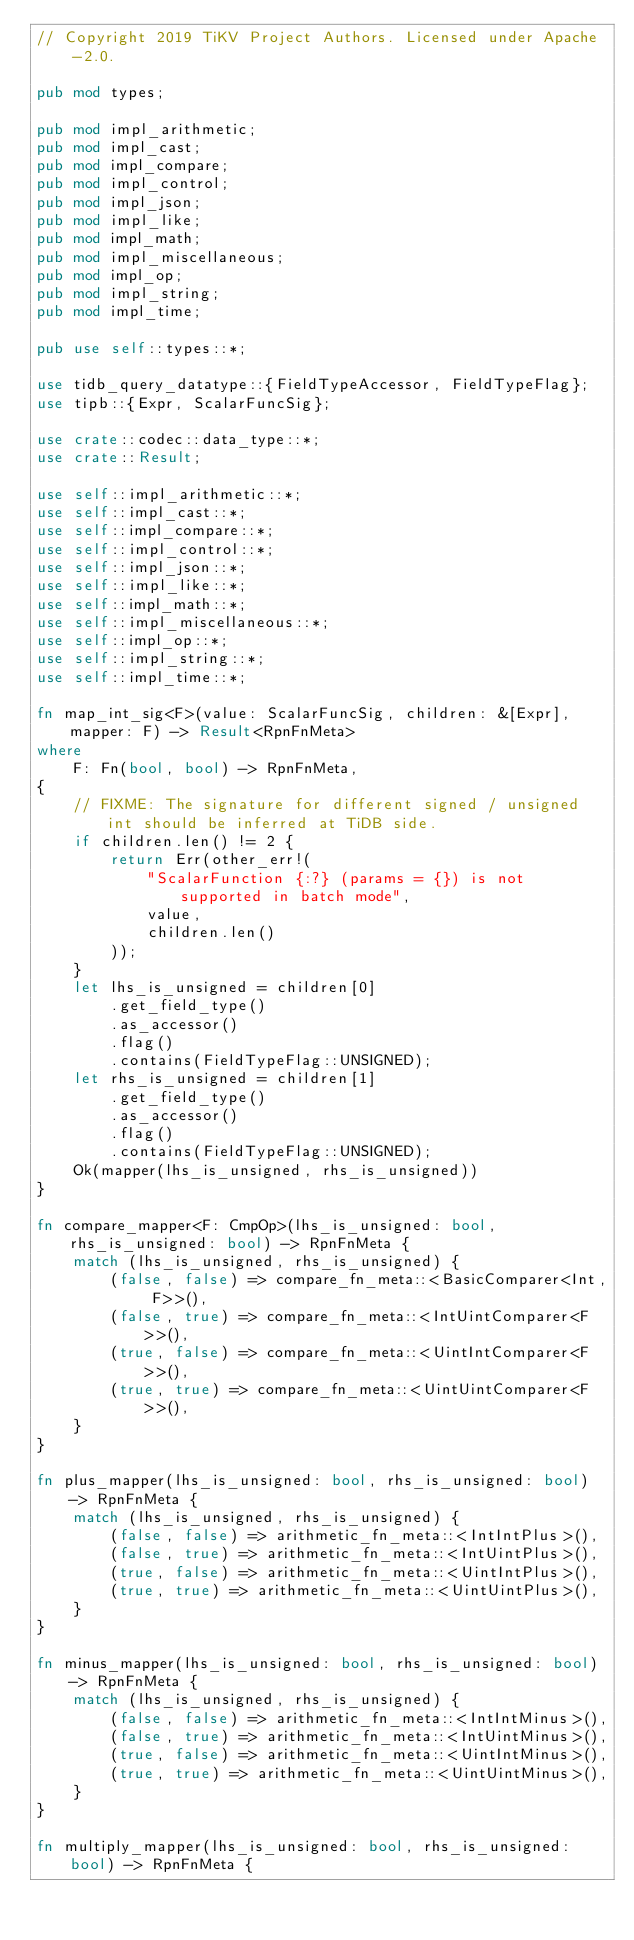<code> <loc_0><loc_0><loc_500><loc_500><_Rust_>// Copyright 2019 TiKV Project Authors. Licensed under Apache-2.0.

pub mod types;

pub mod impl_arithmetic;
pub mod impl_cast;
pub mod impl_compare;
pub mod impl_control;
pub mod impl_json;
pub mod impl_like;
pub mod impl_math;
pub mod impl_miscellaneous;
pub mod impl_op;
pub mod impl_string;
pub mod impl_time;

pub use self::types::*;

use tidb_query_datatype::{FieldTypeAccessor, FieldTypeFlag};
use tipb::{Expr, ScalarFuncSig};

use crate::codec::data_type::*;
use crate::Result;

use self::impl_arithmetic::*;
use self::impl_cast::*;
use self::impl_compare::*;
use self::impl_control::*;
use self::impl_json::*;
use self::impl_like::*;
use self::impl_math::*;
use self::impl_miscellaneous::*;
use self::impl_op::*;
use self::impl_string::*;
use self::impl_time::*;

fn map_int_sig<F>(value: ScalarFuncSig, children: &[Expr], mapper: F) -> Result<RpnFnMeta>
where
    F: Fn(bool, bool) -> RpnFnMeta,
{
    // FIXME: The signature for different signed / unsigned int should be inferred at TiDB side.
    if children.len() != 2 {
        return Err(other_err!(
            "ScalarFunction {:?} (params = {}) is not supported in batch mode",
            value,
            children.len()
        ));
    }
    let lhs_is_unsigned = children[0]
        .get_field_type()
        .as_accessor()
        .flag()
        .contains(FieldTypeFlag::UNSIGNED);
    let rhs_is_unsigned = children[1]
        .get_field_type()
        .as_accessor()
        .flag()
        .contains(FieldTypeFlag::UNSIGNED);
    Ok(mapper(lhs_is_unsigned, rhs_is_unsigned))
}

fn compare_mapper<F: CmpOp>(lhs_is_unsigned: bool, rhs_is_unsigned: bool) -> RpnFnMeta {
    match (lhs_is_unsigned, rhs_is_unsigned) {
        (false, false) => compare_fn_meta::<BasicComparer<Int, F>>(),
        (false, true) => compare_fn_meta::<IntUintComparer<F>>(),
        (true, false) => compare_fn_meta::<UintIntComparer<F>>(),
        (true, true) => compare_fn_meta::<UintUintComparer<F>>(),
    }
}

fn plus_mapper(lhs_is_unsigned: bool, rhs_is_unsigned: bool) -> RpnFnMeta {
    match (lhs_is_unsigned, rhs_is_unsigned) {
        (false, false) => arithmetic_fn_meta::<IntIntPlus>(),
        (false, true) => arithmetic_fn_meta::<IntUintPlus>(),
        (true, false) => arithmetic_fn_meta::<UintIntPlus>(),
        (true, true) => arithmetic_fn_meta::<UintUintPlus>(),
    }
}

fn minus_mapper(lhs_is_unsigned: bool, rhs_is_unsigned: bool) -> RpnFnMeta {
    match (lhs_is_unsigned, rhs_is_unsigned) {
        (false, false) => arithmetic_fn_meta::<IntIntMinus>(),
        (false, true) => arithmetic_fn_meta::<IntUintMinus>(),
        (true, false) => arithmetic_fn_meta::<UintIntMinus>(),
        (true, true) => arithmetic_fn_meta::<UintUintMinus>(),
    }
}

fn multiply_mapper(lhs_is_unsigned: bool, rhs_is_unsigned: bool) -> RpnFnMeta {</code> 